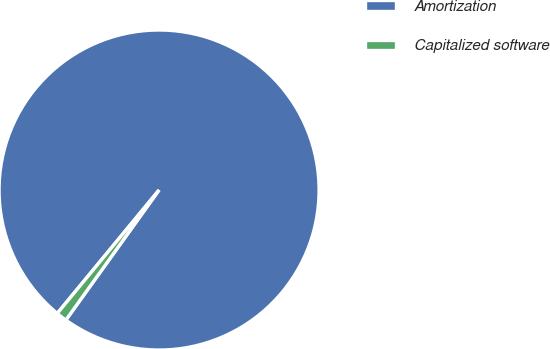Convert chart. <chart><loc_0><loc_0><loc_500><loc_500><pie_chart><fcel>Amortization<fcel>Capitalized software<nl><fcel>98.92%<fcel>1.08%<nl></chart> 